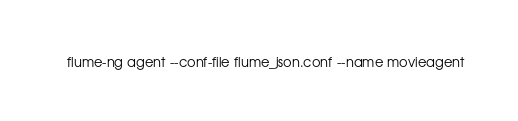Convert code to text. <code><loc_0><loc_0><loc_500><loc_500><_Bash_>flume-ng agent --conf-file flume_json.conf --name movieagent
</code> 